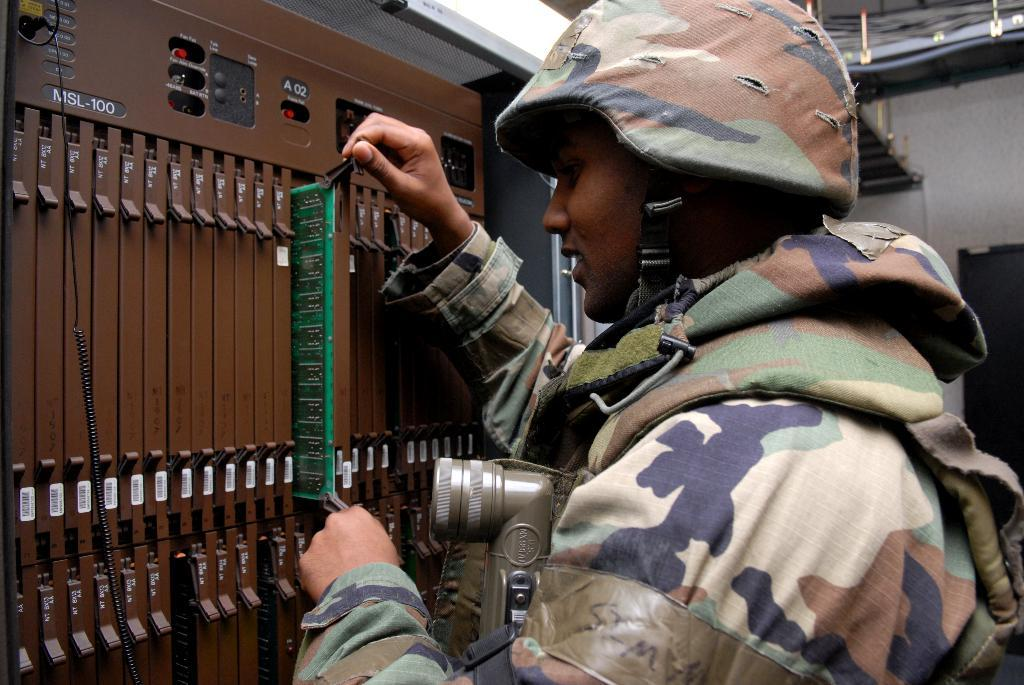What type of machine is in the image? There is an electrical machine in the image. Who is present in the image? There is a person in the image. What is the person holding? The person is holding an object. What else is the person carrying? The person is carrying another object. What can be seen in the background of the image? There is a wall and other unspecified objects in the background of the image. What type of cloth is draped over the electrical machine in the image? There is no cloth draped over the electrical machine in the image. What note is the person singing in the image? There is no indication of the person singing or playing any musical instrument in the image. 